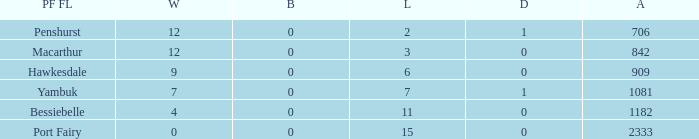How many draws when the Port Fairy FL is Hawkesdale and there are more than 9 wins? None. 